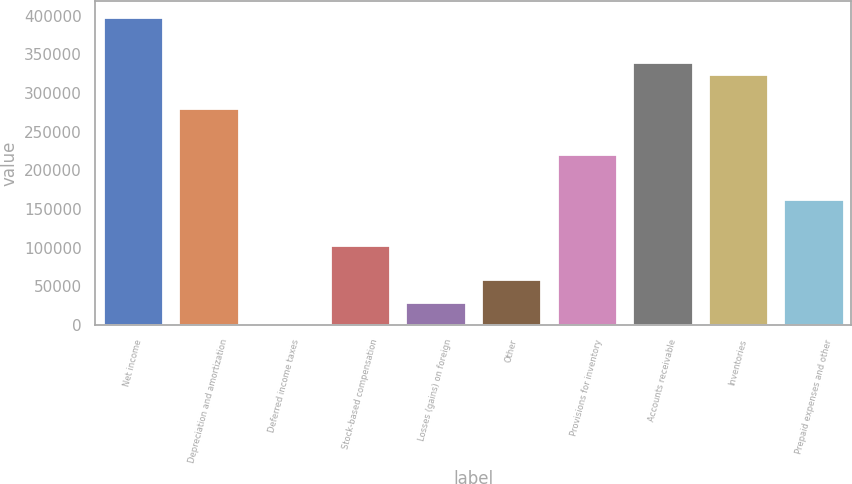Convert chart to OTSL. <chart><loc_0><loc_0><loc_500><loc_500><bar_chart><fcel>Net income<fcel>Depreciation and amortization<fcel>Deferred income taxes<fcel>Stock-based compensation<fcel>Losses (gains) on foreign<fcel>Other<fcel>Provisions for inventory<fcel>Accounts receivable<fcel>Inventories<fcel>Prepaid expenses and other<nl><fcel>398540<fcel>280573<fcel>401<fcel>103622<fcel>29892.8<fcel>59384.6<fcel>221590<fcel>339557<fcel>324811<fcel>162606<nl></chart> 